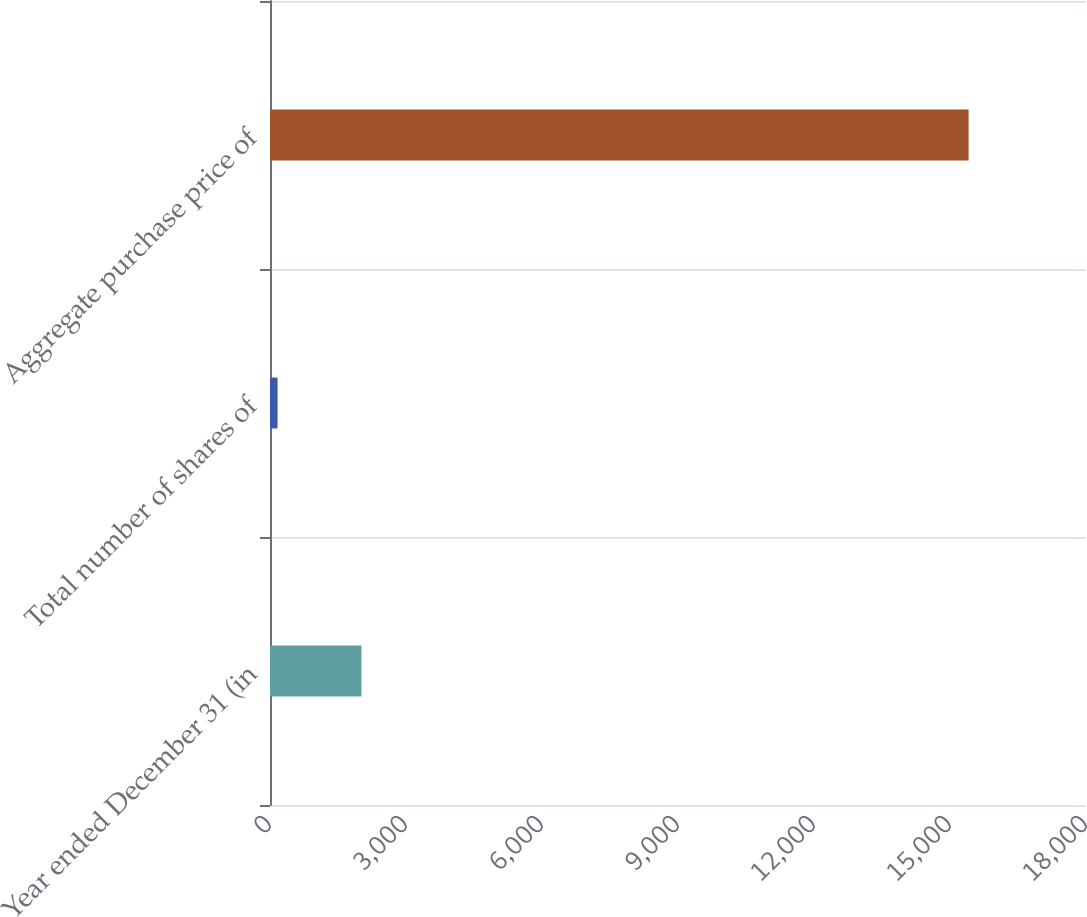<chart> <loc_0><loc_0><loc_500><loc_500><bar_chart><fcel>Year ended December 31 (in<fcel>Total number of shares of<fcel>Aggregate purchase price of<nl><fcel>2017<fcel>166.6<fcel>15410<nl></chart> 